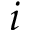Convert formula to latex. <formula><loc_0><loc_0><loc_500><loc_500>i</formula> 